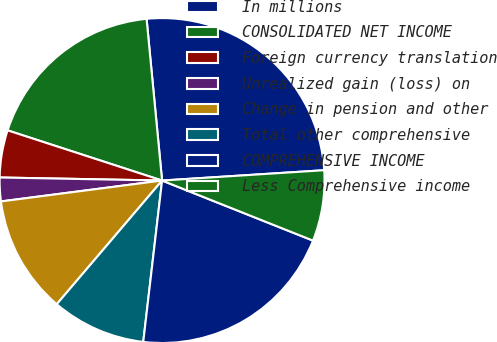Convert chart. <chart><loc_0><loc_0><loc_500><loc_500><pie_chart><fcel>In millions<fcel>CONSOLIDATED NET INCOME<fcel>Foreign currency translation<fcel>Unrealized gain (loss) on<fcel>Change in pension and other<fcel>Total other comprehensive<fcel>COMPREHENSIVE INCOME<fcel>Less Comprehensive income<nl><fcel>25.51%<fcel>18.48%<fcel>4.7%<fcel>2.35%<fcel>11.72%<fcel>9.38%<fcel>20.82%<fcel>7.04%<nl></chart> 